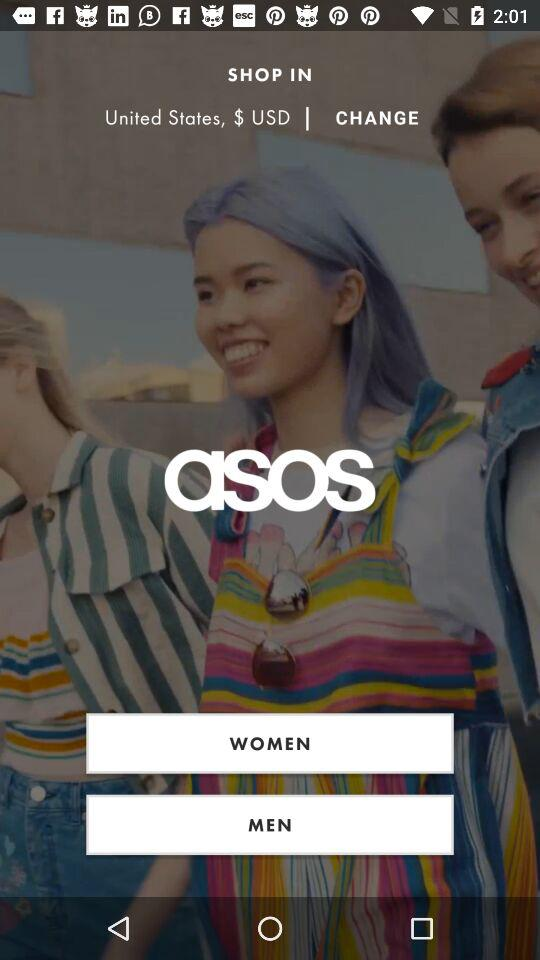What is the location mentioned? The mentioned location is the United States. 